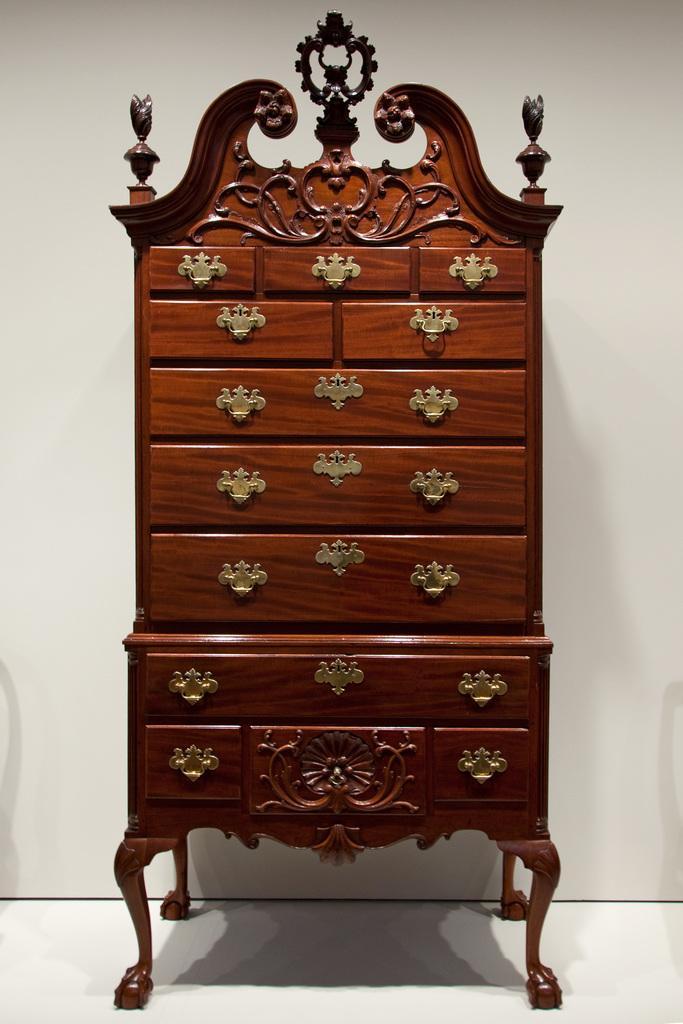How would you summarize this image in a sentence or two? In the image there is a wooden wardrobe,it is carved in a different shape. 